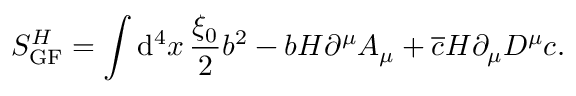Convert formula to latex. <formula><loc_0><loc_0><loc_500><loc_500>S _ { G F } ^ { H } = \int d ^ { 4 } x \, \frac { \xi _ { 0 } } { 2 } b ^ { 2 } - b H \partial ^ { \mu } A _ { \mu } + \overline { c } H \partial _ { \mu } D ^ { \mu } c .</formula> 